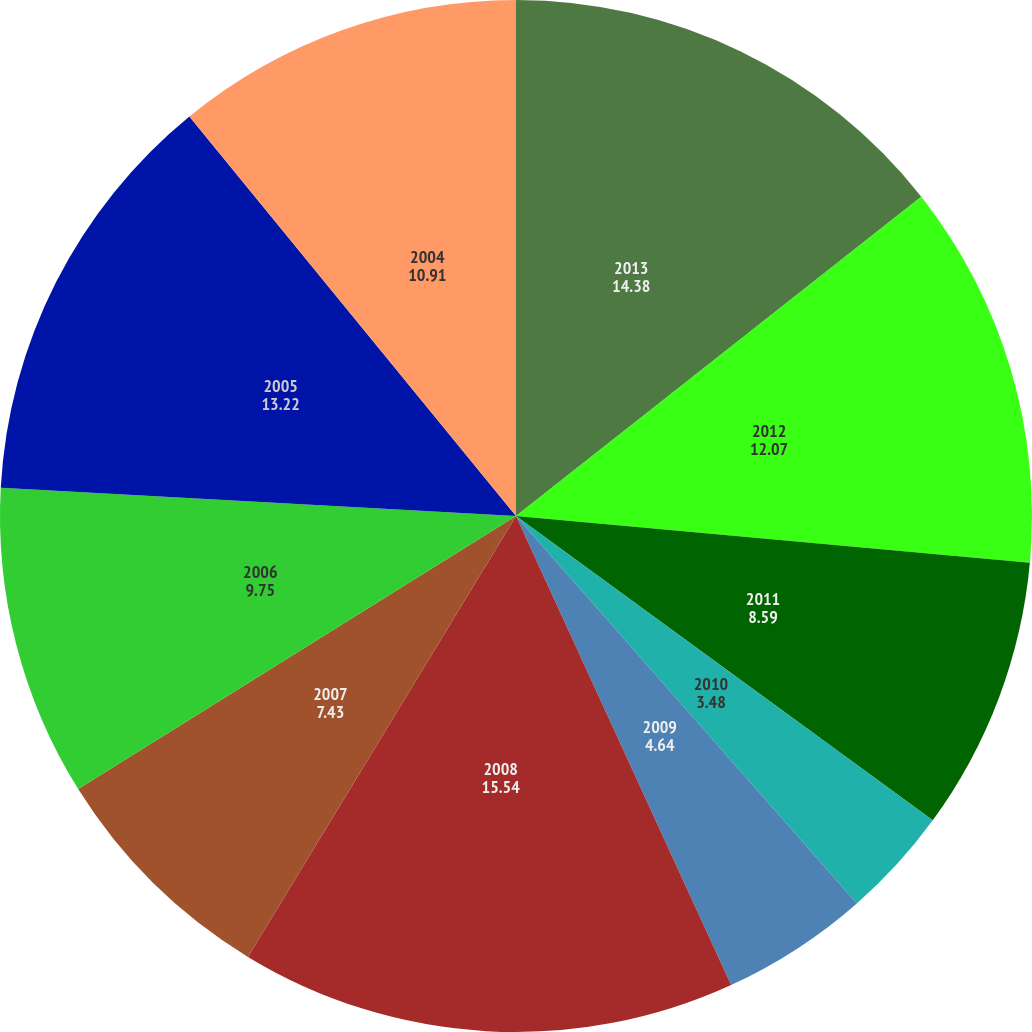Convert chart to OTSL. <chart><loc_0><loc_0><loc_500><loc_500><pie_chart><fcel>2013<fcel>2012<fcel>2011<fcel>2010<fcel>2009<fcel>2008<fcel>2007<fcel>2006<fcel>2005<fcel>2004<nl><fcel>14.38%<fcel>12.07%<fcel>8.59%<fcel>3.48%<fcel>4.64%<fcel>15.54%<fcel>7.43%<fcel>9.75%<fcel>13.22%<fcel>10.91%<nl></chart> 